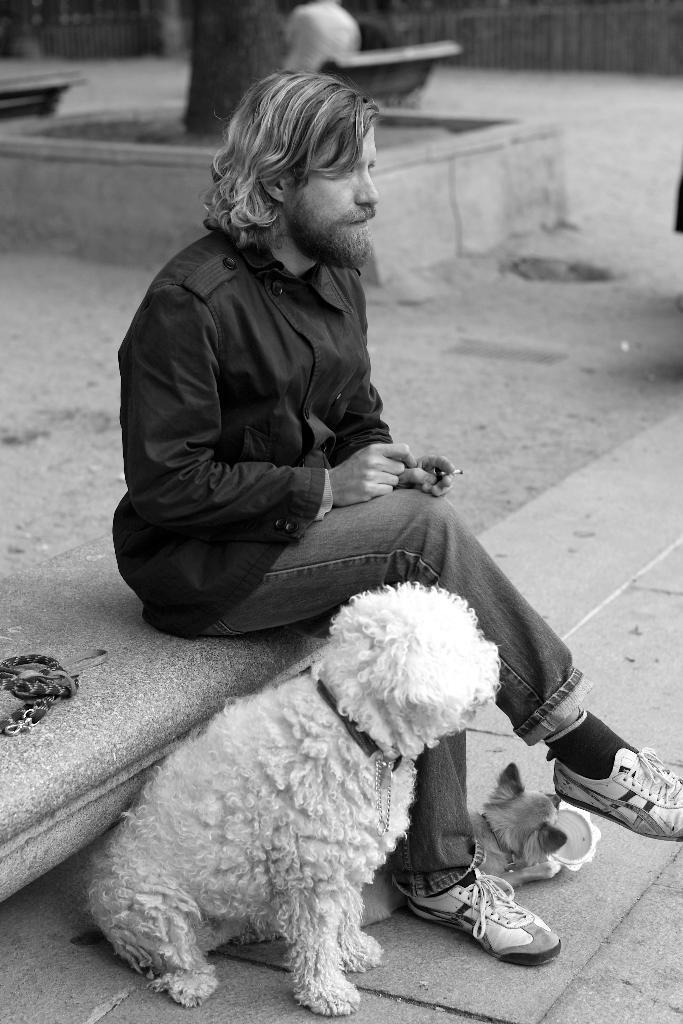What is the color scheme of the image? The image is black and white. What can be seen in the middle of the image? There is a person sitting in the middle of the image. What is located behind the person? There is a dog behind the person. What is unusual about the dog in the image? The dog is wearing a belt. What type of honey can be seen dripping from the drum in the image? There is no drum or honey present in the image. What type of trousers is the person wearing in the image? The image is black and white, so it is difficult to determine the type of trousers the person is wearing. 